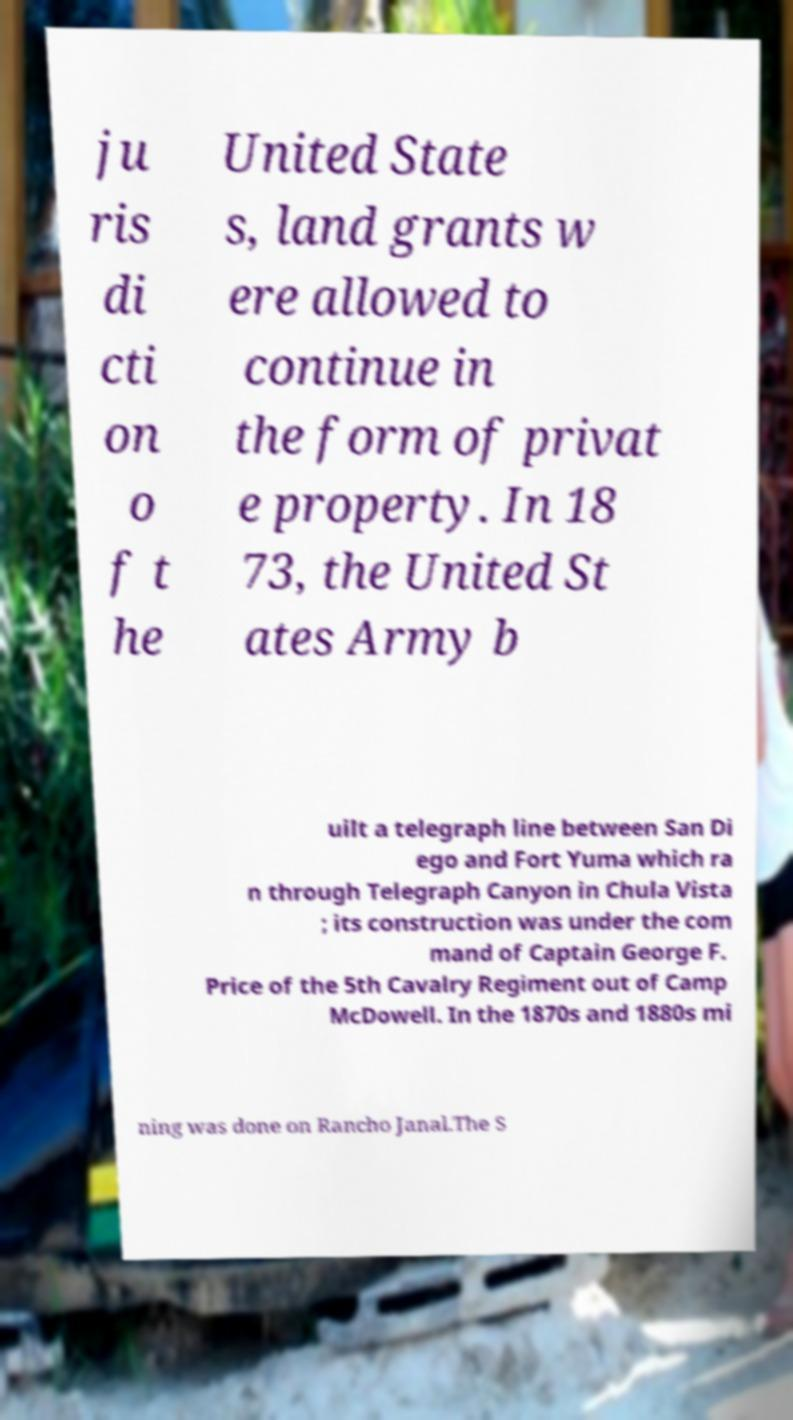For documentation purposes, I need the text within this image transcribed. Could you provide that? ju ris di cti on o f t he United State s, land grants w ere allowed to continue in the form of privat e property. In 18 73, the United St ates Army b uilt a telegraph line between San Di ego and Fort Yuma which ra n through Telegraph Canyon in Chula Vista ; its construction was under the com mand of Captain George F. Price of the 5th Cavalry Regiment out of Camp McDowell. In the 1870s and 1880s mi ning was done on Rancho Janal.The S 